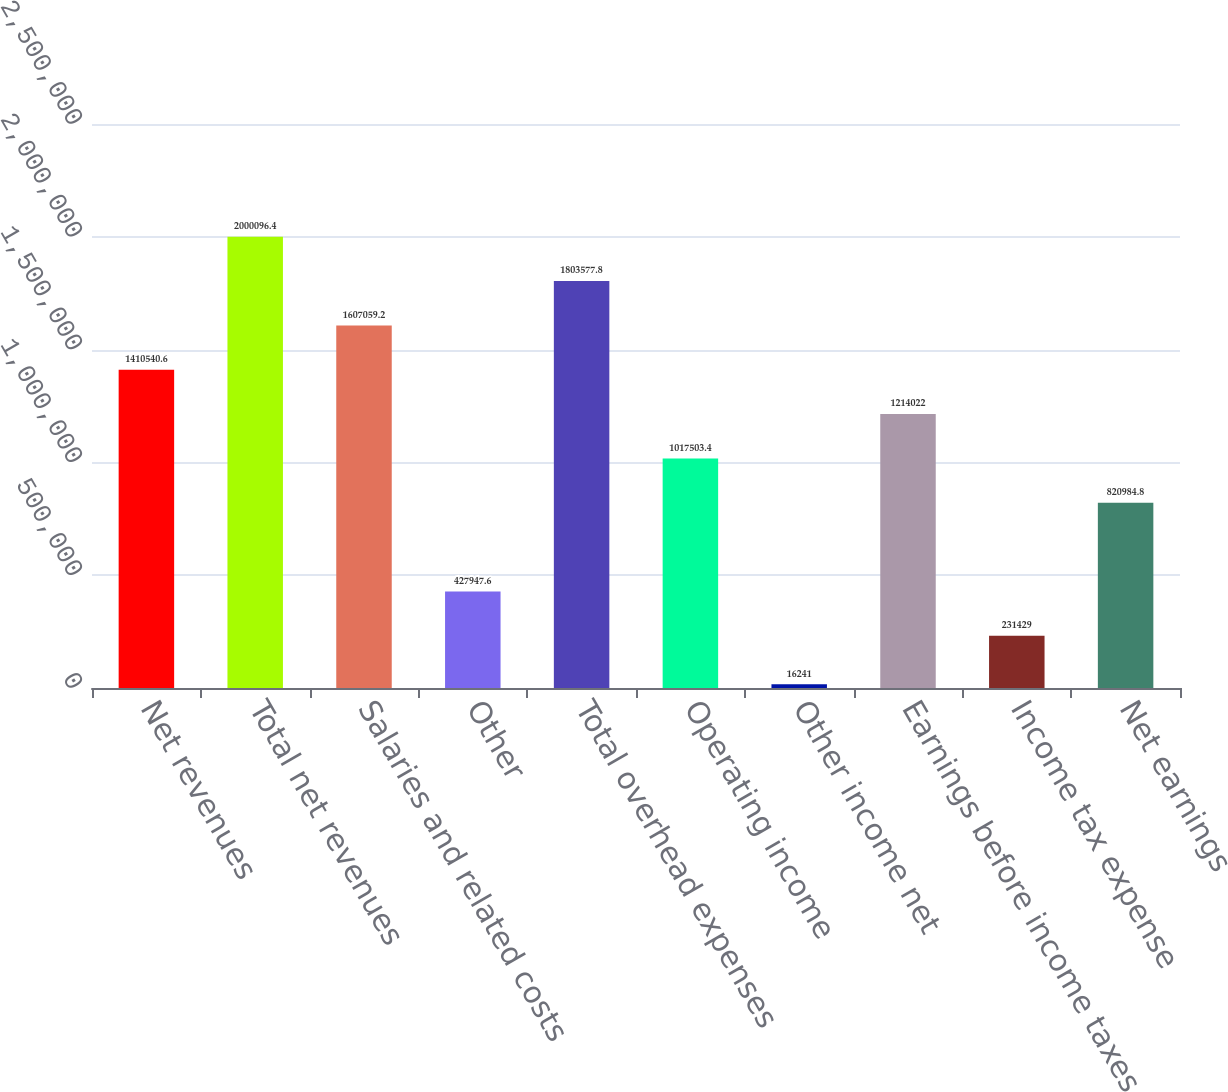Convert chart to OTSL. <chart><loc_0><loc_0><loc_500><loc_500><bar_chart><fcel>Net revenues<fcel>Total net revenues<fcel>Salaries and related costs<fcel>Other<fcel>Total overhead expenses<fcel>Operating income<fcel>Other income net<fcel>Earnings before income taxes<fcel>Income tax expense<fcel>Net earnings<nl><fcel>1.41054e+06<fcel>2.0001e+06<fcel>1.60706e+06<fcel>427948<fcel>1.80358e+06<fcel>1.0175e+06<fcel>16241<fcel>1.21402e+06<fcel>231429<fcel>820985<nl></chart> 